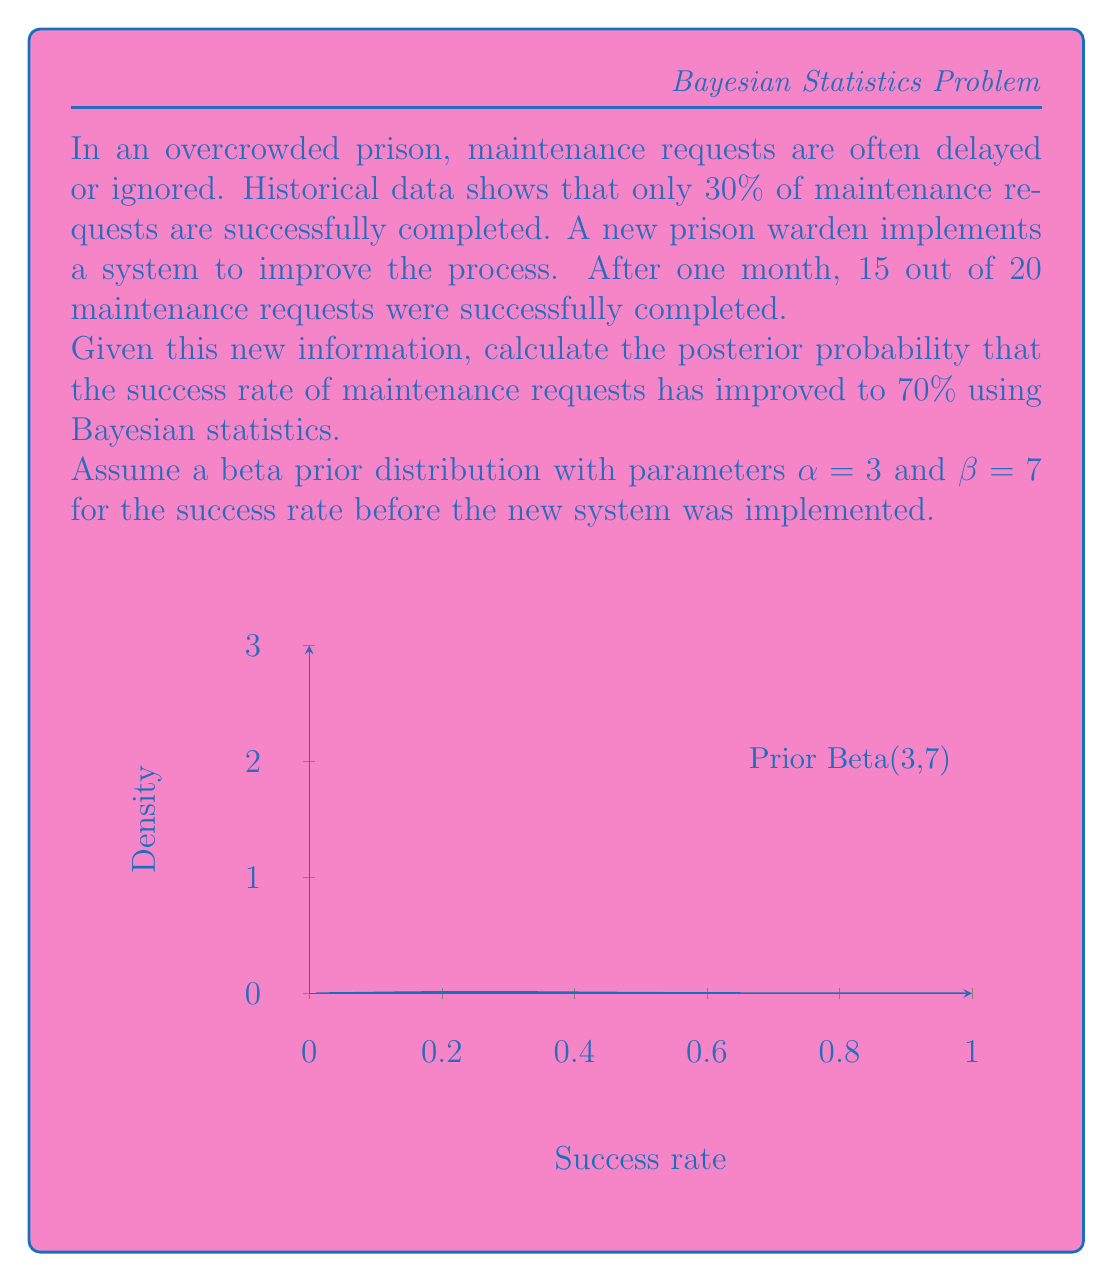Solve this math problem. Let's approach this step-by-step using Bayesian statistics:

1) We start with a prior beta distribution: $\text{Beta}(\alpha=3, \beta=7)$

2) The likelihood of the observed data (15 successes out of 20 trials) follows a binomial distribution.

3) In Bayesian inference with a beta prior and binomial likelihood, the posterior distribution is also a beta distribution with updated parameters:

   $\text{Posterior} = \text{Beta}(\alpha + \text{successes}, \beta + \text{failures})$
   
   $= \text{Beta}(3 + 15, 7 + 5) = \text{Beta}(18, 12)$

4) We want to calculate $P(\theta > 0.7 | \text{data})$, where $\theta$ is the success rate.

5) This probability is the complement of the cumulative distribution function (CDF) of the Beta(18, 12) distribution at 0.7:

   $P(\theta > 0.7 | \text{data}) = 1 - \text{CDF}_{\text{Beta}(18,12)}(0.7)$

6) The CDF of a beta distribution doesn't have a simple closed form. We need to use numerical integration or statistical software to calculate this.

7) Using a statistical calculator or software, we find:

   $\text{CDF}_{\text{Beta}(18,12)}(0.7) \approx 0.9782$

8) Therefore:

   $P(\theta > 0.7 | \text{data}) = 1 - 0.9782 \approx 0.0218$
Answer: $0.0218$ or $2.18\%$ 